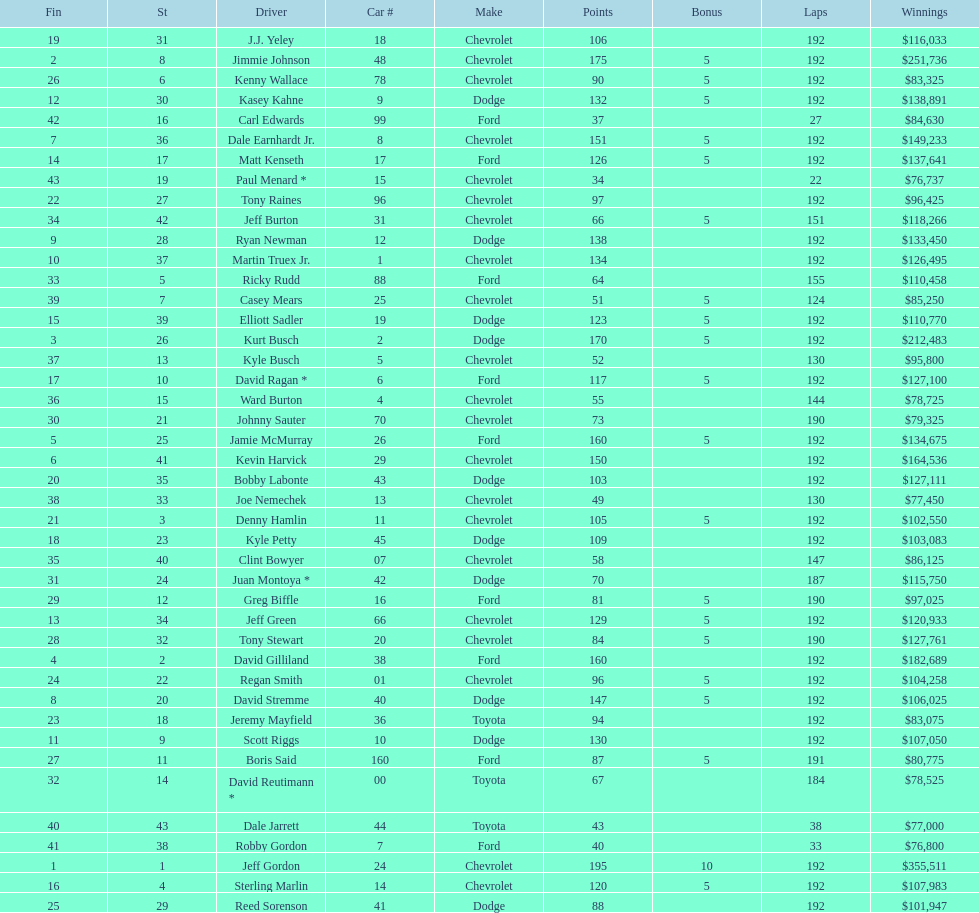What driver earned the least amount of winnings? Paul Menard *. 